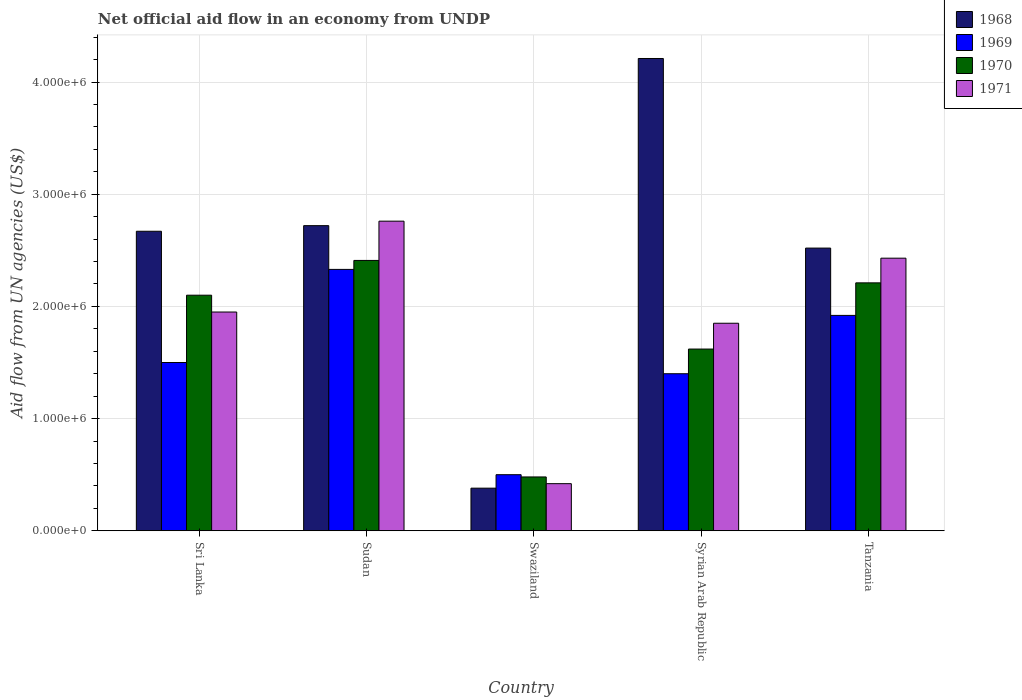How many groups of bars are there?
Offer a terse response. 5. What is the label of the 3rd group of bars from the left?
Provide a succinct answer. Swaziland. What is the net official aid flow in 1968 in Syrian Arab Republic?
Provide a succinct answer. 4.21e+06. Across all countries, what is the maximum net official aid flow in 1969?
Offer a terse response. 2.33e+06. Across all countries, what is the minimum net official aid flow in 1971?
Provide a short and direct response. 4.20e+05. In which country was the net official aid flow in 1968 maximum?
Keep it short and to the point. Syrian Arab Republic. In which country was the net official aid flow in 1970 minimum?
Your response must be concise. Swaziland. What is the total net official aid flow in 1970 in the graph?
Provide a short and direct response. 8.82e+06. What is the difference between the net official aid flow in 1969 in Sri Lanka and that in Tanzania?
Provide a short and direct response. -4.20e+05. What is the difference between the net official aid flow in 1971 in Sri Lanka and the net official aid flow in 1968 in Tanzania?
Offer a very short reply. -5.70e+05. What is the average net official aid flow in 1970 per country?
Offer a very short reply. 1.76e+06. What is the difference between the net official aid flow of/in 1969 and net official aid flow of/in 1970 in Swaziland?
Your answer should be compact. 2.00e+04. What is the ratio of the net official aid flow in 1970 in Sri Lanka to that in Swaziland?
Offer a very short reply. 4.38. What is the difference between the highest and the lowest net official aid flow in 1970?
Make the answer very short. 1.93e+06. In how many countries, is the net official aid flow in 1971 greater than the average net official aid flow in 1971 taken over all countries?
Your answer should be compact. 3. Is the sum of the net official aid flow in 1971 in Sri Lanka and Sudan greater than the maximum net official aid flow in 1968 across all countries?
Your answer should be very brief. Yes. Is it the case that in every country, the sum of the net official aid flow in 1968 and net official aid flow in 1970 is greater than the sum of net official aid flow in 1971 and net official aid flow in 1969?
Keep it short and to the point. No. What does the 4th bar from the left in Tanzania represents?
Your answer should be compact. 1971. How many bars are there?
Give a very brief answer. 20. What is the difference between two consecutive major ticks on the Y-axis?
Offer a terse response. 1.00e+06. Are the values on the major ticks of Y-axis written in scientific E-notation?
Make the answer very short. Yes. Does the graph contain grids?
Ensure brevity in your answer.  Yes. Where does the legend appear in the graph?
Keep it short and to the point. Top right. What is the title of the graph?
Provide a short and direct response. Net official aid flow in an economy from UNDP. Does "1993" appear as one of the legend labels in the graph?
Offer a very short reply. No. What is the label or title of the Y-axis?
Give a very brief answer. Aid flow from UN agencies (US$). What is the Aid flow from UN agencies (US$) of 1968 in Sri Lanka?
Your answer should be compact. 2.67e+06. What is the Aid flow from UN agencies (US$) of 1969 in Sri Lanka?
Your answer should be compact. 1.50e+06. What is the Aid flow from UN agencies (US$) of 1970 in Sri Lanka?
Offer a very short reply. 2.10e+06. What is the Aid flow from UN agencies (US$) in 1971 in Sri Lanka?
Provide a succinct answer. 1.95e+06. What is the Aid flow from UN agencies (US$) in 1968 in Sudan?
Your response must be concise. 2.72e+06. What is the Aid flow from UN agencies (US$) of 1969 in Sudan?
Provide a short and direct response. 2.33e+06. What is the Aid flow from UN agencies (US$) of 1970 in Sudan?
Offer a terse response. 2.41e+06. What is the Aid flow from UN agencies (US$) of 1971 in Sudan?
Your response must be concise. 2.76e+06. What is the Aid flow from UN agencies (US$) in 1969 in Swaziland?
Make the answer very short. 5.00e+05. What is the Aid flow from UN agencies (US$) of 1968 in Syrian Arab Republic?
Your answer should be compact. 4.21e+06. What is the Aid flow from UN agencies (US$) in 1969 in Syrian Arab Republic?
Provide a short and direct response. 1.40e+06. What is the Aid flow from UN agencies (US$) of 1970 in Syrian Arab Republic?
Offer a very short reply. 1.62e+06. What is the Aid flow from UN agencies (US$) of 1971 in Syrian Arab Republic?
Keep it short and to the point. 1.85e+06. What is the Aid flow from UN agencies (US$) in 1968 in Tanzania?
Ensure brevity in your answer.  2.52e+06. What is the Aid flow from UN agencies (US$) of 1969 in Tanzania?
Your answer should be very brief. 1.92e+06. What is the Aid flow from UN agencies (US$) of 1970 in Tanzania?
Provide a succinct answer. 2.21e+06. What is the Aid flow from UN agencies (US$) of 1971 in Tanzania?
Keep it short and to the point. 2.43e+06. Across all countries, what is the maximum Aid flow from UN agencies (US$) in 1968?
Provide a succinct answer. 4.21e+06. Across all countries, what is the maximum Aid flow from UN agencies (US$) of 1969?
Your answer should be very brief. 2.33e+06. Across all countries, what is the maximum Aid flow from UN agencies (US$) in 1970?
Ensure brevity in your answer.  2.41e+06. Across all countries, what is the maximum Aid flow from UN agencies (US$) in 1971?
Keep it short and to the point. 2.76e+06. Across all countries, what is the minimum Aid flow from UN agencies (US$) of 1968?
Ensure brevity in your answer.  3.80e+05. Across all countries, what is the minimum Aid flow from UN agencies (US$) of 1970?
Make the answer very short. 4.80e+05. What is the total Aid flow from UN agencies (US$) in 1968 in the graph?
Provide a short and direct response. 1.25e+07. What is the total Aid flow from UN agencies (US$) of 1969 in the graph?
Provide a short and direct response. 7.65e+06. What is the total Aid flow from UN agencies (US$) in 1970 in the graph?
Your answer should be compact. 8.82e+06. What is the total Aid flow from UN agencies (US$) in 1971 in the graph?
Your answer should be compact. 9.41e+06. What is the difference between the Aid flow from UN agencies (US$) in 1969 in Sri Lanka and that in Sudan?
Your response must be concise. -8.30e+05. What is the difference between the Aid flow from UN agencies (US$) of 1970 in Sri Lanka and that in Sudan?
Give a very brief answer. -3.10e+05. What is the difference between the Aid flow from UN agencies (US$) in 1971 in Sri Lanka and that in Sudan?
Provide a succinct answer. -8.10e+05. What is the difference between the Aid flow from UN agencies (US$) of 1968 in Sri Lanka and that in Swaziland?
Give a very brief answer. 2.29e+06. What is the difference between the Aid flow from UN agencies (US$) in 1969 in Sri Lanka and that in Swaziland?
Give a very brief answer. 1.00e+06. What is the difference between the Aid flow from UN agencies (US$) of 1970 in Sri Lanka and that in Swaziland?
Provide a succinct answer. 1.62e+06. What is the difference between the Aid flow from UN agencies (US$) in 1971 in Sri Lanka and that in Swaziland?
Provide a short and direct response. 1.53e+06. What is the difference between the Aid flow from UN agencies (US$) in 1968 in Sri Lanka and that in Syrian Arab Republic?
Your answer should be very brief. -1.54e+06. What is the difference between the Aid flow from UN agencies (US$) in 1971 in Sri Lanka and that in Syrian Arab Republic?
Provide a short and direct response. 1.00e+05. What is the difference between the Aid flow from UN agencies (US$) in 1968 in Sri Lanka and that in Tanzania?
Your response must be concise. 1.50e+05. What is the difference between the Aid flow from UN agencies (US$) in 1969 in Sri Lanka and that in Tanzania?
Keep it short and to the point. -4.20e+05. What is the difference between the Aid flow from UN agencies (US$) in 1970 in Sri Lanka and that in Tanzania?
Keep it short and to the point. -1.10e+05. What is the difference between the Aid flow from UN agencies (US$) in 1971 in Sri Lanka and that in Tanzania?
Provide a succinct answer. -4.80e+05. What is the difference between the Aid flow from UN agencies (US$) of 1968 in Sudan and that in Swaziland?
Your answer should be very brief. 2.34e+06. What is the difference between the Aid flow from UN agencies (US$) of 1969 in Sudan and that in Swaziland?
Provide a succinct answer. 1.83e+06. What is the difference between the Aid flow from UN agencies (US$) of 1970 in Sudan and that in Swaziland?
Make the answer very short. 1.93e+06. What is the difference between the Aid flow from UN agencies (US$) of 1971 in Sudan and that in Swaziland?
Keep it short and to the point. 2.34e+06. What is the difference between the Aid flow from UN agencies (US$) of 1968 in Sudan and that in Syrian Arab Republic?
Your answer should be compact. -1.49e+06. What is the difference between the Aid flow from UN agencies (US$) in 1969 in Sudan and that in Syrian Arab Republic?
Provide a succinct answer. 9.30e+05. What is the difference between the Aid flow from UN agencies (US$) of 1970 in Sudan and that in Syrian Arab Republic?
Your answer should be very brief. 7.90e+05. What is the difference between the Aid flow from UN agencies (US$) in 1971 in Sudan and that in Syrian Arab Republic?
Provide a short and direct response. 9.10e+05. What is the difference between the Aid flow from UN agencies (US$) in 1968 in Sudan and that in Tanzania?
Your answer should be very brief. 2.00e+05. What is the difference between the Aid flow from UN agencies (US$) of 1969 in Sudan and that in Tanzania?
Provide a short and direct response. 4.10e+05. What is the difference between the Aid flow from UN agencies (US$) of 1970 in Sudan and that in Tanzania?
Provide a short and direct response. 2.00e+05. What is the difference between the Aid flow from UN agencies (US$) of 1968 in Swaziland and that in Syrian Arab Republic?
Offer a terse response. -3.83e+06. What is the difference between the Aid flow from UN agencies (US$) in 1969 in Swaziland and that in Syrian Arab Republic?
Your response must be concise. -9.00e+05. What is the difference between the Aid flow from UN agencies (US$) of 1970 in Swaziland and that in Syrian Arab Republic?
Offer a terse response. -1.14e+06. What is the difference between the Aid flow from UN agencies (US$) in 1971 in Swaziland and that in Syrian Arab Republic?
Give a very brief answer. -1.43e+06. What is the difference between the Aid flow from UN agencies (US$) of 1968 in Swaziland and that in Tanzania?
Provide a succinct answer. -2.14e+06. What is the difference between the Aid flow from UN agencies (US$) of 1969 in Swaziland and that in Tanzania?
Offer a terse response. -1.42e+06. What is the difference between the Aid flow from UN agencies (US$) in 1970 in Swaziland and that in Tanzania?
Make the answer very short. -1.73e+06. What is the difference between the Aid flow from UN agencies (US$) of 1971 in Swaziland and that in Tanzania?
Your answer should be very brief. -2.01e+06. What is the difference between the Aid flow from UN agencies (US$) of 1968 in Syrian Arab Republic and that in Tanzania?
Offer a terse response. 1.69e+06. What is the difference between the Aid flow from UN agencies (US$) in 1969 in Syrian Arab Republic and that in Tanzania?
Offer a very short reply. -5.20e+05. What is the difference between the Aid flow from UN agencies (US$) in 1970 in Syrian Arab Republic and that in Tanzania?
Your answer should be compact. -5.90e+05. What is the difference between the Aid flow from UN agencies (US$) in 1971 in Syrian Arab Republic and that in Tanzania?
Provide a succinct answer. -5.80e+05. What is the difference between the Aid flow from UN agencies (US$) of 1968 in Sri Lanka and the Aid flow from UN agencies (US$) of 1969 in Sudan?
Keep it short and to the point. 3.40e+05. What is the difference between the Aid flow from UN agencies (US$) of 1968 in Sri Lanka and the Aid flow from UN agencies (US$) of 1970 in Sudan?
Make the answer very short. 2.60e+05. What is the difference between the Aid flow from UN agencies (US$) of 1968 in Sri Lanka and the Aid flow from UN agencies (US$) of 1971 in Sudan?
Offer a terse response. -9.00e+04. What is the difference between the Aid flow from UN agencies (US$) in 1969 in Sri Lanka and the Aid flow from UN agencies (US$) in 1970 in Sudan?
Your answer should be compact. -9.10e+05. What is the difference between the Aid flow from UN agencies (US$) in 1969 in Sri Lanka and the Aid flow from UN agencies (US$) in 1971 in Sudan?
Provide a succinct answer. -1.26e+06. What is the difference between the Aid flow from UN agencies (US$) of 1970 in Sri Lanka and the Aid flow from UN agencies (US$) of 1971 in Sudan?
Offer a very short reply. -6.60e+05. What is the difference between the Aid flow from UN agencies (US$) of 1968 in Sri Lanka and the Aid flow from UN agencies (US$) of 1969 in Swaziland?
Offer a very short reply. 2.17e+06. What is the difference between the Aid flow from UN agencies (US$) in 1968 in Sri Lanka and the Aid flow from UN agencies (US$) in 1970 in Swaziland?
Give a very brief answer. 2.19e+06. What is the difference between the Aid flow from UN agencies (US$) of 1968 in Sri Lanka and the Aid flow from UN agencies (US$) of 1971 in Swaziland?
Your answer should be compact. 2.25e+06. What is the difference between the Aid flow from UN agencies (US$) in 1969 in Sri Lanka and the Aid flow from UN agencies (US$) in 1970 in Swaziland?
Offer a terse response. 1.02e+06. What is the difference between the Aid flow from UN agencies (US$) of 1969 in Sri Lanka and the Aid flow from UN agencies (US$) of 1971 in Swaziland?
Your answer should be compact. 1.08e+06. What is the difference between the Aid flow from UN agencies (US$) in 1970 in Sri Lanka and the Aid flow from UN agencies (US$) in 1971 in Swaziland?
Make the answer very short. 1.68e+06. What is the difference between the Aid flow from UN agencies (US$) of 1968 in Sri Lanka and the Aid flow from UN agencies (US$) of 1969 in Syrian Arab Republic?
Make the answer very short. 1.27e+06. What is the difference between the Aid flow from UN agencies (US$) of 1968 in Sri Lanka and the Aid flow from UN agencies (US$) of 1970 in Syrian Arab Republic?
Your response must be concise. 1.05e+06. What is the difference between the Aid flow from UN agencies (US$) of 1968 in Sri Lanka and the Aid flow from UN agencies (US$) of 1971 in Syrian Arab Republic?
Offer a terse response. 8.20e+05. What is the difference between the Aid flow from UN agencies (US$) of 1969 in Sri Lanka and the Aid flow from UN agencies (US$) of 1970 in Syrian Arab Republic?
Keep it short and to the point. -1.20e+05. What is the difference between the Aid flow from UN agencies (US$) of 1969 in Sri Lanka and the Aid flow from UN agencies (US$) of 1971 in Syrian Arab Republic?
Your answer should be very brief. -3.50e+05. What is the difference between the Aid flow from UN agencies (US$) of 1968 in Sri Lanka and the Aid flow from UN agencies (US$) of 1969 in Tanzania?
Provide a short and direct response. 7.50e+05. What is the difference between the Aid flow from UN agencies (US$) of 1968 in Sri Lanka and the Aid flow from UN agencies (US$) of 1970 in Tanzania?
Offer a very short reply. 4.60e+05. What is the difference between the Aid flow from UN agencies (US$) in 1969 in Sri Lanka and the Aid flow from UN agencies (US$) in 1970 in Tanzania?
Keep it short and to the point. -7.10e+05. What is the difference between the Aid flow from UN agencies (US$) in 1969 in Sri Lanka and the Aid flow from UN agencies (US$) in 1971 in Tanzania?
Keep it short and to the point. -9.30e+05. What is the difference between the Aid flow from UN agencies (US$) in 1970 in Sri Lanka and the Aid flow from UN agencies (US$) in 1971 in Tanzania?
Your response must be concise. -3.30e+05. What is the difference between the Aid flow from UN agencies (US$) in 1968 in Sudan and the Aid flow from UN agencies (US$) in 1969 in Swaziland?
Make the answer very short. 2.22e+06. What is the difference between the Aid flow from UN agencies (US$) of 1968 in Sudan and the Aid flow from UN agencies (US$) of 1970 in Swaziland?
Offer a very short reply. 2.24e+06. What is the difference between the Aid flow from UN agencies (US$) of 1968 in Sudan and the Aid flow from UN agencies (US$) of 1971 in Swaziland?
Ensure brevity in your answer.  2.30e+06. What is the difference between the Aid flow from UN agencies (US$) of 1969 in Sudan and the Aid flow from UN agencies (US$) of 1970 in Swaziland?
Keep it short and to the point. 1.85e+06. What is the difference between the Aid flow from UN agencies (US$) in 1969 in Sudan and the Aid flow from UN agencies (US$) in 1971 in Swaziland?
Your answer should be very brief. 1.91e+06. What is the difference between the Aid flow from UN agencies (US$) of 1970 in Sudan and the Aid flow from UN agencies (US$) of 1971 in Swaziland?
Offer a terse response. 1.99e+06. What is the difference between the Aid flow from UN agencies (US$) of 1968 in Sudan and the Aid flow from UN agencies (US$) of 1969 in Syrian Arab Republic?
Offer a very short reply. 1.32e+06. What is the difference between the Aid flow from UN agencies (US$) in 1968 in Sudan and the Aid flow from UN agencies (US$) in 1970 in Syrian Arab Republic?
Your answer should be compact. 1.10e+06. What is the difference between the Aid flow from UN agencies (US$) of 1968 in Sudan and the Aid flow from UN agencies (US$) of 1971 in Syrian Arab Republic?
Your answer should be compact. 8.70e+05. What is the difference between the Aid flow from UN agencies (US$) of 1969 in Sudan and the Aid flow from UN agencies (US$) of 1970 in Syrian Arab Republic?
Offer a terse response. 7.10e+05. What is the difference between the Aid flow from UN agencies (US$) of 1970 in Sudan and the Aid flow from UN agencies (US$) of 1971 in Syrian Arab Republic?
Your answer should be very brief. 5.60e+05. What is the difference between the Aid flow from UN agencies (US$) of 1968 in Sudan and the Aid flow from UN agencies (US$) of 1970 in Tanzania?
Provide a short and direct response. 5.10e+05. What is the difference between the Aid flow from UN agencies (US$) of 1968 in Sudan and the Aid flow from UN agencies (US$) of 1971 in Tanzania?
Offer a terse response. 2.90e+05. What is the difference between the Aid flow from UN agencies (US$) of 1969 in Sudan and the Aid flow from UN agencies (US$) of 1970 in Tanzania?
Offer a very short reply. 1.20e+05. What is the difference between the Aid flow from UN agencies (US$) of 1968 in Swaziland and the Aid flow from UN agencies (US$) of 1969 in Syrian Arab Republic?
Offer a very short reply. -1.02e+06. What is the difference between the Aid flow from UN agencies (US$) of 1968 in Swaziland and the Aid flow from UN agencies (US$) of 1970 in Syrian Arab Republic?
Ensure brevity in your answer.  -1.24e+06. What is the difference between the Aid flow from UN agencies (US$) of 1968 in Swaziland and the Aid flow from UN agencies (US$) of 1971 in Syrian Arab Republic?
Provide a succinct answer. -1.47e+06. What is the difference between the Aid flow from UN agencies (US$) in 1969 in Swaziland and the Aid flow from UN agencies (US$) in 1970 in Syrian Arab Republic?
Your answer should be compact. -1.12e+06. What is the difference between the Aid flow from UN agencies (US$) of 1969 in Swaziland and the Aid flow from UN agencies (US$) of 1971 in Syrian Arab Republic?
Provide a succinct answer. -1.35e+06. What is the difference between the Aid flow from UN agencies (US$) in 1970 in Swaziland and the Aid flow from UN agencies (US$) in 1971 in Syrian Arab Republic?
Your response must be concise. -1.37e+06. What is the difference between the Aid flow from UN agencies (US$) in 1968 in Swaziland and the Aid flow from UN agencies (US$) in 1969 in Tanzania?
Offer a terse response. -1.54e+06. What is the difference between the Aid flow from UN agencies (US$) of 1968 in Swaziland and the Aid flow from UN agencies (US$) of 1970 in Tanzania?
Your answer should be very brief. -1.83e+06. What is the difference between the Aid flow from UN agencies (US$) in 1968 in Swaziland and the Aid flow from UN agencies (US$) in 1971 in Tanzania?
Provide a succinct answer. -2.05e+06. What is the difference between the Aid flow from UN agencies (US$) in 1969 in Swaziland and the Aid flow from UN agencies (US$) in 1970 in Tanzania?
Your answer should be compact. -1.71e+06. What is the difference between the Aid flow from UN agencies (US$) in 1969 in Swaziland and the Aid flow from UN agencies (US$) in 1971 in Tanzania?
Provide a short and direct response. -1.93e+06. What is the difference between the Aid flow from UN agencies (US$) of 1970 in Swaziland and the Aid flow from UN agencies (US$) of 1971 in Tanzania?
Your answer should be very brief. -1.95e+06. What is the difference between the Aid flow from UN agencies (US$) in 1968 in Syrian Arab Republic and the Aid flow from UN agencies (US$) in 1969 in Tanzania?
Make the answer very short. 2.29e+06. What is the difference between the Aid flow from UN agencies (US$) of 1968 in Syrian Arab Republic and the Aid flow from UN agencies (US$) of 1970 in Tanzania?
Make the answer very short. 2.00e+06. What is the difference between the Aid flow from UN agencies (US$) in 1968 in Syrian Arab Republic and the Aid flow from UN agencies (US$) in 1971 in Tanzania?
Your response must be concise. 1.78e+06. What is the difference between the Aid flow from UN agencies (US$) in 1969 in Syrian Arab Republic and the Aid flow from UN agencies (US$) in 1970 in Tanzania?
Make the answer very short. -8.10e+05. What is the difference between the Aid flow from UN agencies (US$) of 1969 in Syrian Arab Republic and the Aid flow from UN agencies (US$) of 1971 in Tanzania?
Provide a succinct answer. -1.03e+06. What is the difference between the Aid flow from UN agencies (US$) in 1970 in Syrian Arab Republic and the Aid flow from UN agencies (US$) in 1971 in Tanzania?
Give a very brief answer. -8.10e+05. What is the average Aid flow from UN agencies (US$) in 1968 per country?
Offer a terse response. 2.50e+06. What is the average Aid flow from UN agencies (US$) of 1969 per country?
Keep it short and to the point. 1.53e+06. What is the average Aid flow from UN agencies (US$) of 1970 per country?
Offer a very short reply. 1.76e+06. What is the average Aid flow from UN agencies (US$) of 1971 per country?
Ensure brevity in your answer.  1.88e+06. What is the difference between the Aid flow from UN agencies (US$) of 1968 and Aid flow from UN agencies (US$) of 1969 in Sri Lanka?
Your answer should be very brief. 1.17e+06. What is the difference between the Aid flow from UN agencies (US$) of 1968 and Aid flow from UN agencies (US$) of 1970 in Sri Lanka?
Your answer should be compact. 5.70e+05. What is the difference between the Aid flow from UN agencies (US$) in 1968 and Aid flow from UN agencies (US$) in 1971 in Sri Lanka?
Your response must be concise. 7.20e+05. What is the difference between the Aid flow from UN agencies (US$) of 1969 and Aid flow from UN agencies (US$) of 1970 in Sri Lanka?
Offer a terse response. -6.00e+05. What is the difference between the Aid flow from UN agencies (US$) in 1969 and Aid flow from UN agencies (US$) in 1971 in Sri Lanka?
Provide a succinct answer. -4.50e+05. What is the difference between the Aid flow from UN agencies (US$) in 1968 and Aid flow from UN agencies (US$) in 1969 in Sudan?
Provide a short and direct response. 3.90e+05. What is the difference between the Aid flow from UN agencies (US$) of 1968 and Aid flow from UN agencies (US$) of 1971 in Sudan?
Give a very brief answer. -4.00e+04. What is the difference between the Aid flow from UN agencies (US$) of 1969 and Aid flow from UN agencies (US$) of 1971 in Sudan?
Your answer should be compact. -4.30e+05. What is the difference between the Aid flow from UN agencies (US$) of 1970 and Aid flow from UN agencies (US$) of 1971 in Sudan?
Give a very brief answer. -3.50e+05. What is the difference between the Aid flow from UN agencies (US$) of 1968 and Aid flow from UN agencies (US$) of 1969 in Swaziland?
Keep it short and to the point. -1.20e+05. What is the difference between the Aid flow from UN agencies (US$) in 1968 and Aid flow from UN agencies (US$) in 1970 in Swaziland?
Make the answer very short. -1.00e+05. What is the difference between the Aid flow from UN agencies (US$) in 1968 and Aid flow from UN agencies (US$) in 1971 in Swaziland?
Keep it short and to the point. -4.00e+04. What is the difference between the Aid flow from UN agencies (US$) of 1970 and Aid flow from UN agencies (US$) of 1971 in Swaziland?
Keep it short and to the point. 6.00e+04. What is the difference between the Aid flow from UN agencies (US$) in 1968 and Aid flow from UN agencies (US$) in 1969 in Syrian Arab Republic?
Your answer should be very brief. 2.81e+06. What is the difference between the Aid flow from UN agencies (US$) in 1968 and Aid flow from UN agencies (US$) in 1970 in Syrian Arab Republic?
Offer a terse response. 2.59e+06. What is the difference between the Aid flow from UN agencies (US$) of 1968 and Aid flow from UN agencies (US$) of 1971 in Syrian Arab Republic?
Make the answer very short. 2.36e+06. What is the difference between the Aid flow from UN agencies (US$) in 1969 and Aid flow from UN agencies (US$) in 1970 in Syrian Arab Republic?
Your answer should be compact. -2.20e+05. What is the difference between the Aid flow from UN agencies (US$) in 1969 and Aid flow from UN agencies (US$) in 1971 in Syrian Arab Republic?
Ensure brevity in your answer.  -4.50e+05. What is the difference between the Aid flow from UN agencies (US$) in 1970 and Aid flow from UN agencies (US$) in 1971 in Syrian Arab Republic?
Provide a short and direct response. -2.30e+05. What is the difference between the Aid flow from UN agencies (US$) in 1968 and Aid flow from UN agencies (US$) in 1970 in Tanzania?
Provide a succinct answer. 3.10e+05. What is the difference between the Aid flow from UN agencies (US$) of 1969 and Aid flow from UN agencies (US$) of 1971 in Tanzania?
Offer a very short reply. -5.10e+05. What is the ratio of the Aid flow from UN agencies (US$) in 1968 in Sri Lanka to that in Sudan?
Give a very brief answer. 0.98. What is the ratio of the Aid flow from UN agencies (US$) of 1969 in Sri Lanka to that in Sudan?
Provide a succinct answer. 0.64. What is the ratio of the Aid flow from UN agencies (US$) of 1970 in Sri Lanka to that in Sudan?
Ensure brevity in your answer.  0.87. What is the ratio of the Aid flow from UN agencies (US$) in 1971 in Sri Lanka to that in Sudan?
Offer a terse response. 0.71. What is the ratio of the Aid flow from UN agencies (US$) in 1968 in Sri Lanka to that in Swaziland?
Your answer should be compact. 7.03. What is the ratio of the Aid flow from UN agencies (US$) in 1969 in Sri Lanka to that in Swaziland?
Provide a succinct answer. 3. What is the ratio of the Aid flow from UN agencies (US$) in 1970 in Sri Lanka to that in Swaziland?
Give a very brief answer. 4.38. What is the ratio of the Aid flow from UN agencies (US$) of 1971 in Sri Lanka to that in Swaziland?
Your response must be concise. 4.64. What is the ratio of the Aid flow from UN agencies (US$) in 1968 in Sri Lanka to that in Syrian Arab Republic?
Your answer should be compact. 0.63. What is the ratio of the Aid flow from UN agencies (US$) of 1969 in Sri Lanka to that in Syrian Arab Republic?
Your answer should be compact. 1.07. What is the ratio of the Aid flow from UN agencies (US$) of 1970 in Sri Lanka to that in Syrian Arab Republic?
Your answer should be very brief. 1.3. What is the ratio of the Aid flow from UN agencies (US$) in 1971 in Sri Lanka to that in Syrian Arab Republic?
Provide a short and direct response. 1.05. What is the ratio of the Aid flow from UN agencies (US$) in 1968 in Sri Lanka to that in Tanzania?
Offer a very short reply. 1.06. What is the ratio of the Aid flow from UN agencies (US$) in 1969 in Sri Lanka to that in Tanzania?
Your answer should be very brief. 0.78. What is the ratio of the Aid flow from UN agencies (US$) in 1970 in Sri Lanka to that in Tanzania?
Make the answer very short. 0.95. What is the ratio of the Aid flow from UN agencies (US$) in 1971 in Sri Lanka to that in Tanzania?
Your answer should be very brief. 0.8. What is the ratio of the Aid flow from UN agencies (US$) of 1968 in Sudan to that in Swaziland?
Offer a very short reply. 7.16. What is the ratio of the Aid flow from UN agencies (US$) of 1969 in Sudan to that in Swaziland?
Offer a terse response. 4.66. What is the ratio of the Aid flow from UN agencies (US$) of 1970 in Sudan to that in Swaziland?
Ensure brevity in your answer.  5.02. What is the ratio of the Aid flow from UN agencies (US$) in 1971 in Sudan to that in Swaziland?
Keep it short and to the point. 6.57. What is the ratio of the Aid flow from UN agencies (US$) of 1968 in Sudan to that in Syrian Arab Republic?
Provide a succinct answer. 0.65. What is the ratio of the Aid flow from UN agencies (US$) in 1969 in Sudan to that in Syrian Arab Republic?
Ensure brevity in your answer.  1.66. What is the ratio of the Aid flow from UN agencies (US$) of 1970 in Sudan to that in Syrian Arab Republic?
Give a very brief answer. 1.49. What is the ratio of the Aid flow from UN agencies (US$) in 1971 in Sudan to that in Syrian Arab Republic?
Keep it short and to the point. 1.49. What is the ratio of the Aid flow from UN agencies (US$) in 1968 in Sudan to that in Tanzania?
Give a very brief answer. 1.08. What is the ratio of the Aid flow from UN agencies (US$) in 1969 in Sudan to that in Tanzania?
Your answer should be compact. 1.21. What is the ratio of the Aid flow from UN agencies (US$) of 1970 in Sudan to that in Tanzania?
Ensure brevity in your answer.  1.09. What is the ratio of the Aid flow from UN agencies (US$) of 1971 in Sudan to that in Tanzania?
Make the answer very short. 1.14. What is the ratio of the Aid flow from UN agencies (US$) of 1968 in Swaziland to that in Syrian Arab Republic?
Provide a short and direct response. 0.09. What is the ratio of the Aid flow from UN agencies (US$) of 1969 in Swaziland to that in Syrian Arab Republic?
Your response must be concise. 0.36. What is the ratio of the Aid flow from UN agencies (US$) of 1970 in Swaziland to that in Syrian Arab Republic?
Your response must be concise. 0.3. What is the ratio of the Aid flow from UN agencies (US$) of 1971 in Swaziland to that in Syrian Arab Republic?
Offer a terse response. 0.23. What is the ratio of the Aid flow from UN agencies (US$) in 1968 in Swaziland to that in Tanzania?
Ensure brevity in your answer.  0.15. What is the ratio of the Aid flow from UN agencies (US$) in 1969 in Swaziland to that in Tanzania?
Keep it short and to the point. 0.26. What is the ratio of the Aid flow from UN agencies (US$) of 1970 in Swaziland to that in Tanzania?
Your answer should be very brief. 0.22. What is the ratio of the Aid flow from UN agencies (US$) in 1971 in Swaziland to that in Tanzania?
Give a very brief answer. 0.17. What is the ratio of the Aid flow from UN agencies (US$) in 1968 in Syrian Arab Republic to that in Tanzania?
Offer a terse response. 1.67. What is the ratio of the Aid flow from UN agencies (US$) of 1969 in Syrian Arab Republic to that in Tanzania?
Your answer should be very brief. 0.73. What is the ratio of the Aid flow from UN agencies (US$) in 1970 in Syrian Arab Republic to that in Tanzania?
Offer a very short reply. 0.73. What is the ratio of the Aid flow from UN agencies (US$) in 1971 in Syrian Arab Republic to that in Tanzania?
Offer a terse response. 0.76. What is the difference between the highest and the second highest Aid flow from UN agencies (US$) in 1968?
Make the answer very short. 1.49e+06. What is the difference between the highest and the second highest Aid flow from UN agencies (US$) of 1970?
Your response must be concise. 2.00e+05. What is the difference between the highest and the lowest Aid flow from UN agencies (US$) in 1968?
Your answer should be very brief. 3.83e+06. What is the difference between the highest and the lowest Aid flow from UN agencies (US$) of 1969?
Make the answer very short. 1.83e+06. What is the difference between the highest and the lowest Aid flow from UN agencies (US$) of 1970?
Offer a terse response. 1.93e+06. What is the difference between the highest and the lowest Aid flow from UN agencies (US$) of 1971?
Give a very brief answer. 2.34e+06. 